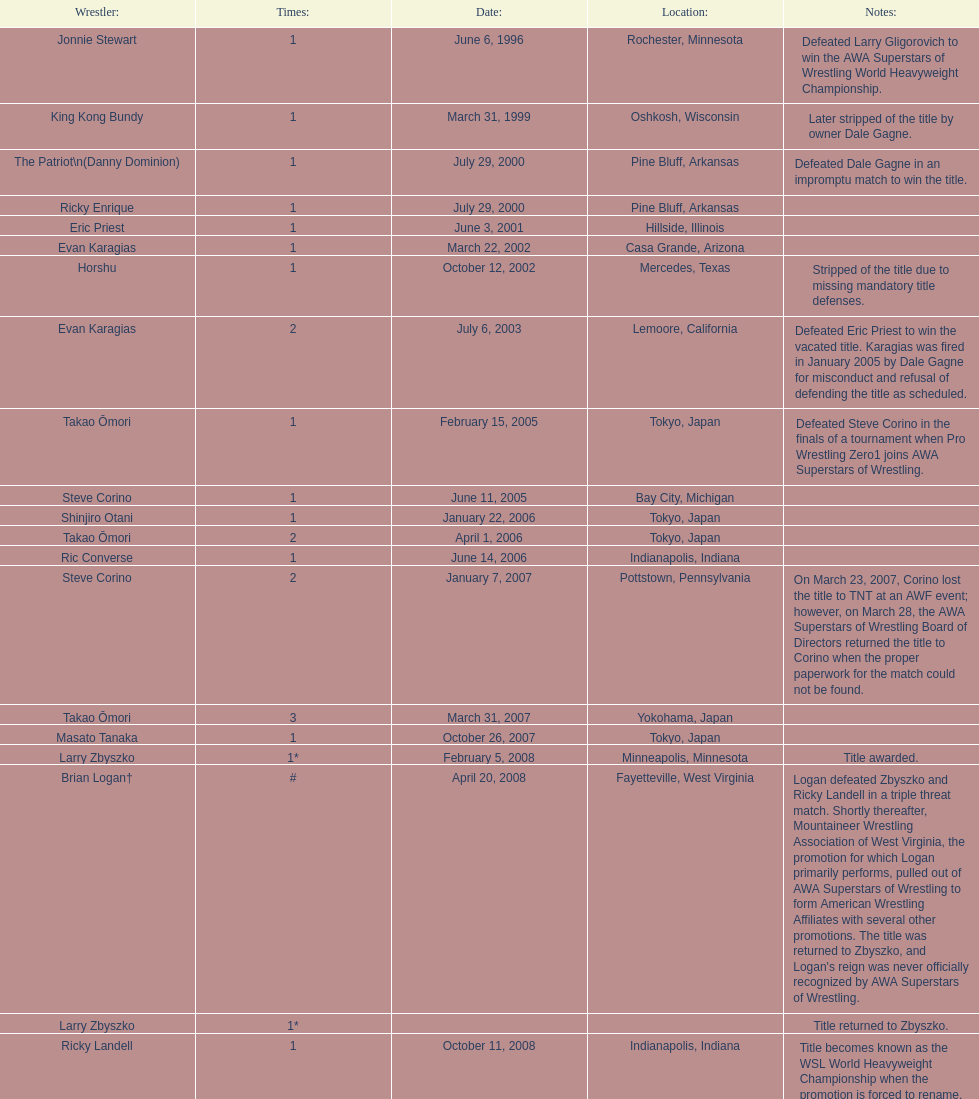How many different men held the wsl title before horshu won his first wsl title? 6. 